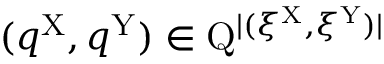<formula> <loc_0><loc_0><loc_500><loc_500>( q ^ { X } , q ^ { Y } ) \in Q ^ { | ( \xi ^ { X } , \xi ^ { Y } ) | }</formula> 